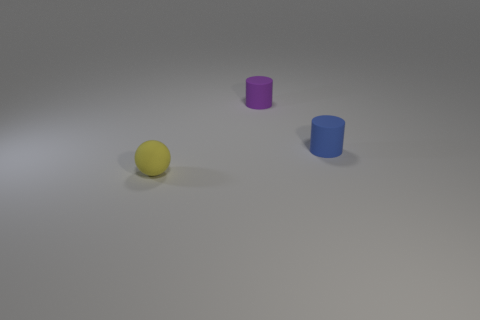Add 3 tiny brown balls. How many objects exist? 6 Subtract all balls. How many objects are left? 2 Add 2 small yellow matte things. How many small yellow matte things are left? 3 Add 2 tiny purple balls. How many tiny purple balls exist? 2 Subtract 0 purple balls. How many objects are left? 3 Subtract all tiny blue matte cylinders. Subtract all small yellow balls. How many objects are left? 1 